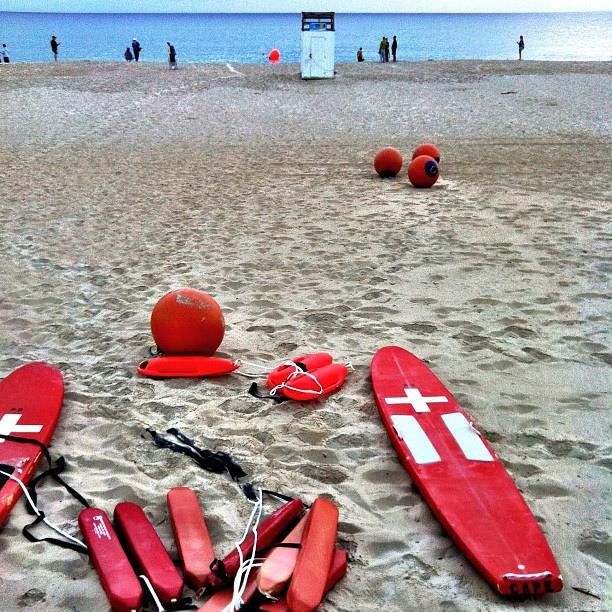Who does this gear on the beach belong to? Please explain your reasoning. lifeguard. The red color indicates the items are used by the lifeguards on the beach. 